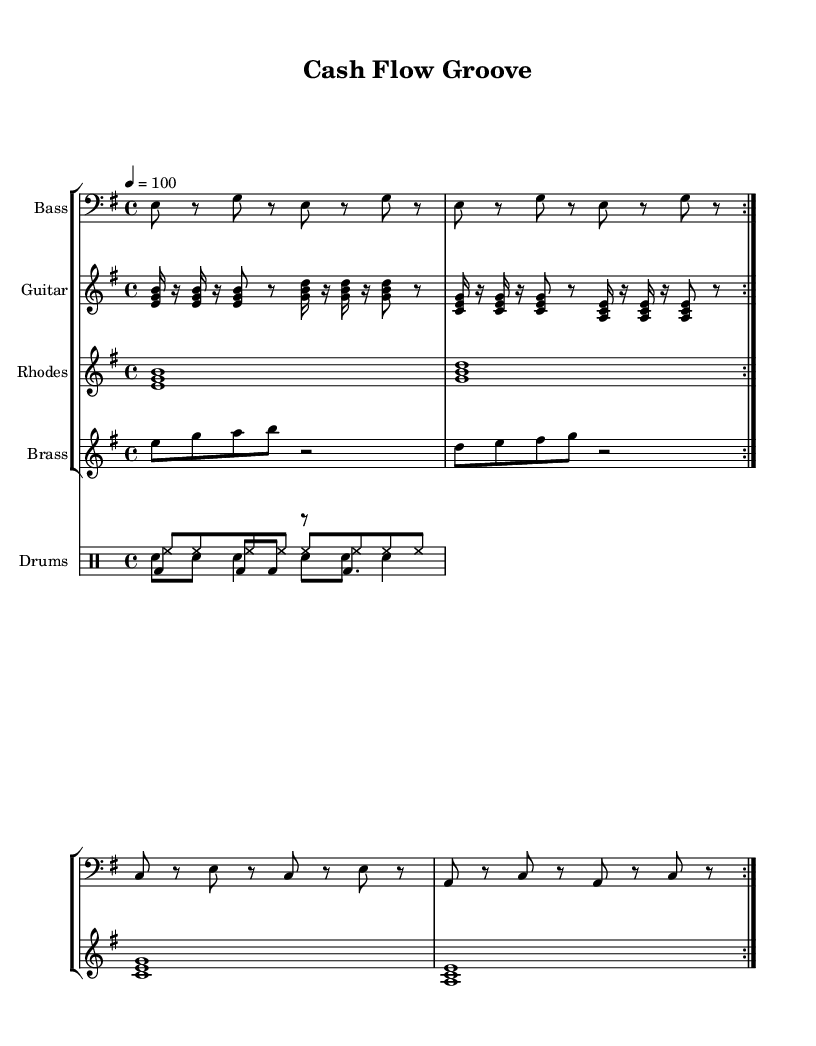What is the key signature of this music? The key signature is indicated at the beginning of the music sheet, and it shows E minor, which has one sharp (F#).
Answer: E minor What is the time signature of the piece? The time signature is located at the beginning of the sheet music and is shown as 4/4, which means there are four beats in each measure.
Answer: 4/4 What is the tempo marking for this piece? The tempo marking is indicated in the score and reads "4 = 100," implying there are 100 beats per minute.
Answer: 100 How many measures are in the bass line section? The bass line is repeated for two volta sections, and each section consists of four measures, resulting in a total of eight measures.
Answer: 8 What instruments are featured in this arrangement? The instruments are listed at the beginning of each staff in the score, which includes Bass, Guitar, Rhodes, Brass, and Drums.
Answer: Bass, Guitar, Rhodes, Brass, Drums Which instrument has a repeated rhythm of three notes? The guitar rhythm section features repeated triplet notes as indicated by the grouping of three notes on multiple occasions in each measure.
Answer: Guitar What musical characteristic is prominent in this funk style? The sheet music has syncopated rhythms and a strong groove, which are typical characteristics of funk music emphasizing off-beat accents.
Answer: Syncopation 